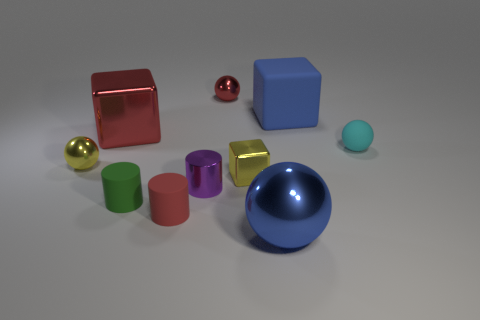There is a large metal thing behind the cyan thing that is behind the large ball; is there a big metallic sphere that is right of it?
Your response must be concise. Yes. What is the small ball that is to the left of the small metal cylinder made of?
Offer a terse response. Metal. Is the size of the rubber ball the same as the yellow ball?
Offer a very short reply. Yes. There is a small sphere that is both on the left side of the tiny metallic block and in front of the red metallic ball; what color is it?
Offer a terse response. Yellow. The large blue thing that is made of the same material as the big red cube is what shape?
Your answer should be very brief. Sphere. How many large things are both to the right of the green matte cylinder and behind the cyan sphere?
Make the answer very short. 1. Are there any small cylinders right of the small yellow metallic ball?
Offer a terse response. Yes. There is a small red thing behind the small purple object; is it the same shape as the thing to the right of the blue block?
Offer a very short reply. Yes. How many things are either green cubes or yellow metallic things that are to the left of the green thing?
Offer a terse response. 1. How many other objects are the same shape as the tiny cyan thing?
Offer a very short reply. 3. 